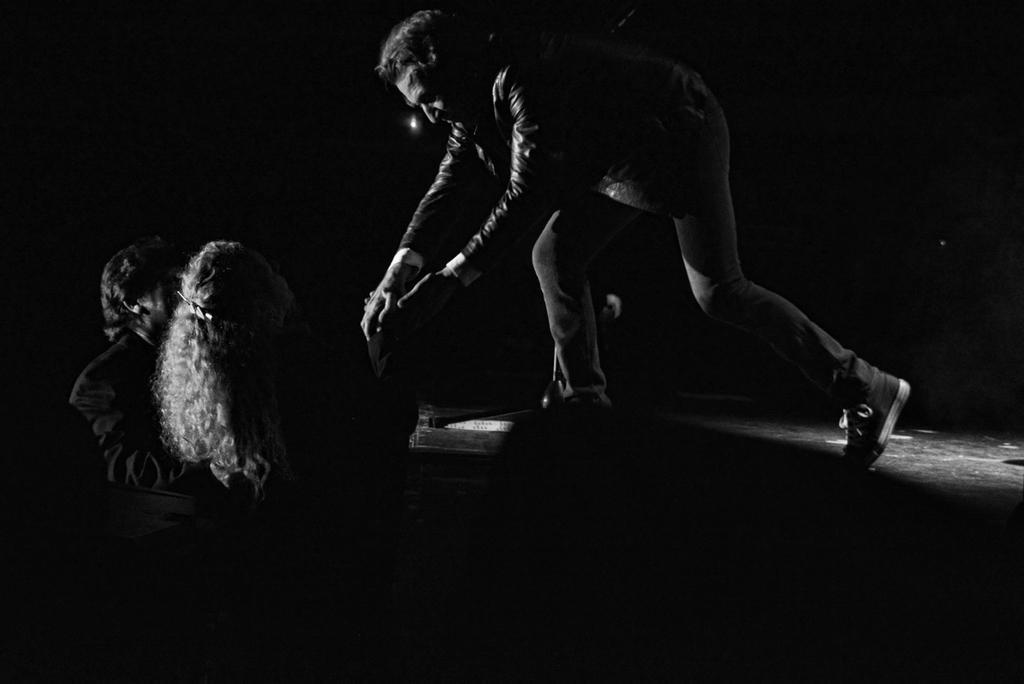Could you give a brief overview of what you see in this image? In the center of the image there is a person standing on the dais. On the left side of the image we can see man and woman standing at the dais. In the background there is a light 